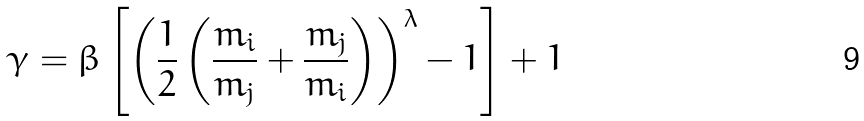Convert formula to latex. <formula><loc_0><loc_0><loc_500><loc_500>\gamma = \beta \left [ \left ( \frac { 1 } { 2 } \left ( \frac { m _ { i } } { m _ { j } } + \frac { m _ { j } } { m _ { i } } \right ) \right ) ^ { \lambda } - 1 \right ] + 1</formula> 